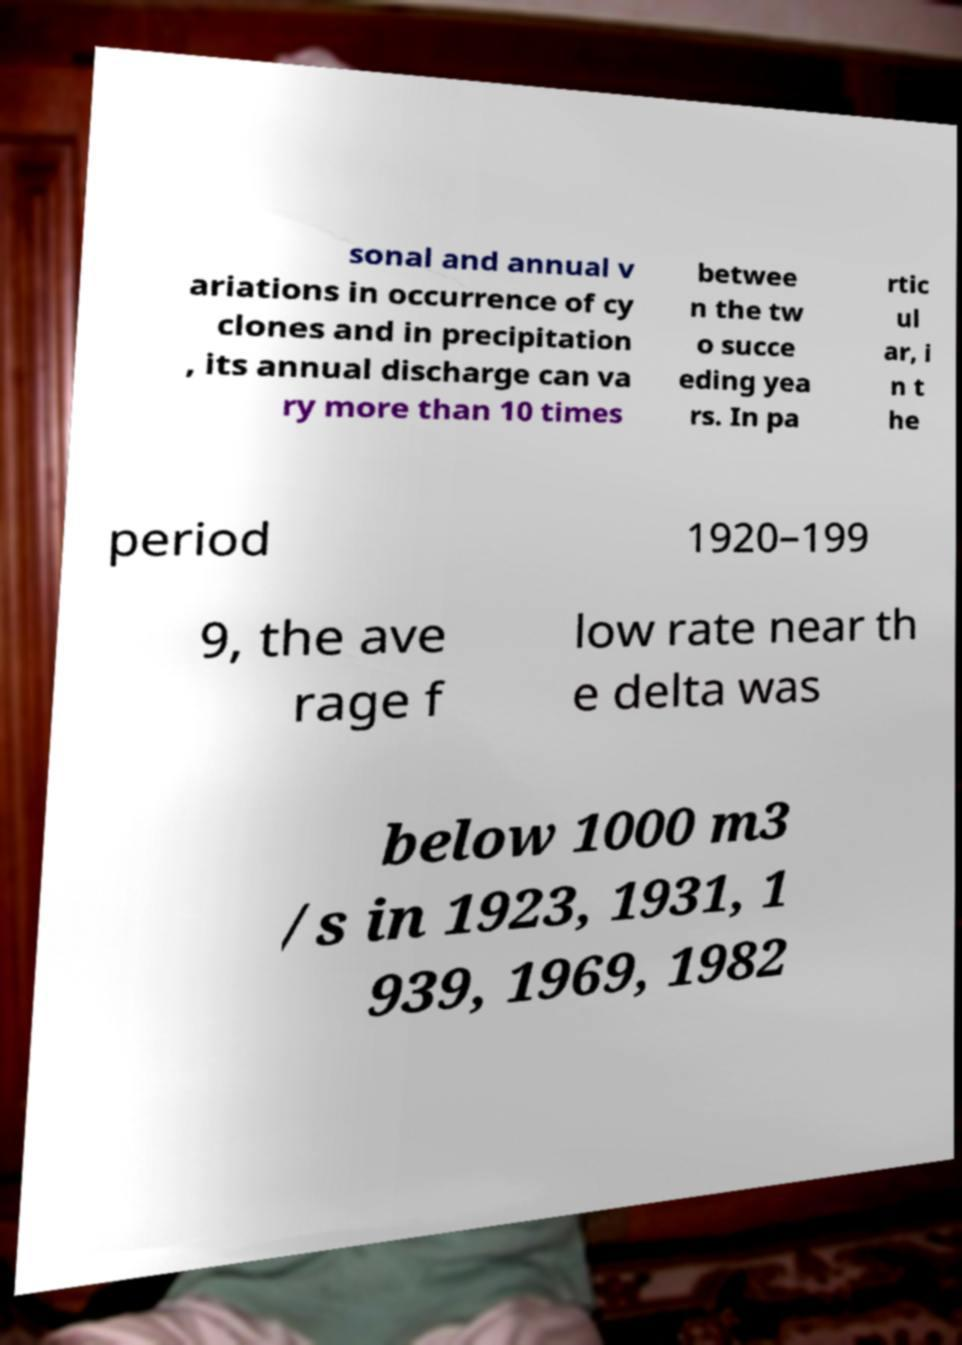Can you read and provide the text displayed in the image?This photo seems to have some interesting text. Can you extract and type it out for me? sonal and annual v ariations in occurrence of cy clones and in precipitation , its annual discharge can va ry more than 10 times betwee n the tw o succe eding yea rs. In pa rtic ul ar, i n t he period 1920–199 9, the ave rage f low rate near th e delta was below 1000 m3 /s in 1923, 1931, 1 939, 1969, 1982 